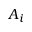Convert formula to latex. <formula><loc_0><loc_0><loc_500><loc_500>A _ { i }</formula> 